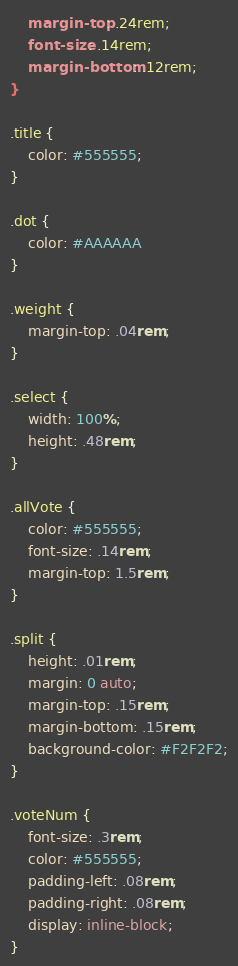Convert code to text. <code><loc_0><loc_0><loc_500><loc_500><_CSS_>    margin-top: .24rem;
    font-size: .14rem;
    margin-bottom: .12rem;
}

.title {
    color: #555555;
}

.dot {
    color: #AAAAAA
}

.weight {
    margin-top: .04rem;
}

.select {
    width: 100%;
    height: .48rem;
}

.allVote {
    color: #555555;
    font-size: .14rem;
    margin-top: 1.5rem;
}

.split {
    height: .01rem;
    margin: 0 auto;
    margin-top: .15rem;
    margin-bottom: .15rem;
    background-color: #F2F2F2;
}

.voteNum {
    font-size: .3rem;
    color: #555555;
    padding-left: .08rem;
    padding-right: .08rem;
    display: inline-block;
}</code> 